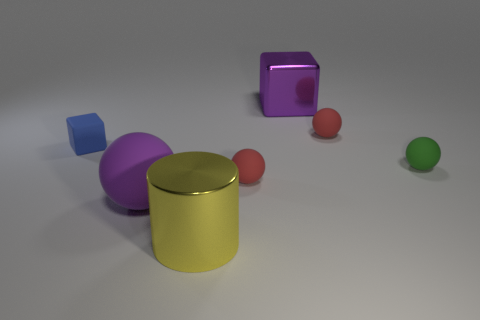What is the size of the rubber sphere left of the metallic object in front of the purple metallic block?
Your response must be concise. Large. What number of other objects are the same color as the cylinder?
Keep it short and to the point. 0. What is the material of the yellow cylinder?
Your response must be concise. Metal. Is there a tiny matte thing?
Make the answer very short. Yes. Are there an equal number of metallic cylinders that are to the right of the green matte thing and metal balls?
Give a very brief answer. Yes. What number of large objects are either metal things or yellow metal balls?
Ensure brevity in your answer.  2. There is a big matte thing that is the same color as the large metallic cube; what shape is it?
Keep it short and to the point. Sphere. Does the tiny red ball behind the tiny blue object have the same material as the purple ball?
Offer a terse response. Yes. What material is the block behind the rubber thing that is left of the big rubber object?
Give a very brief answer. Metal. What number of purple shiny objects are the same shape as the green rubber thing?
Provide a short and direct response. 0. 